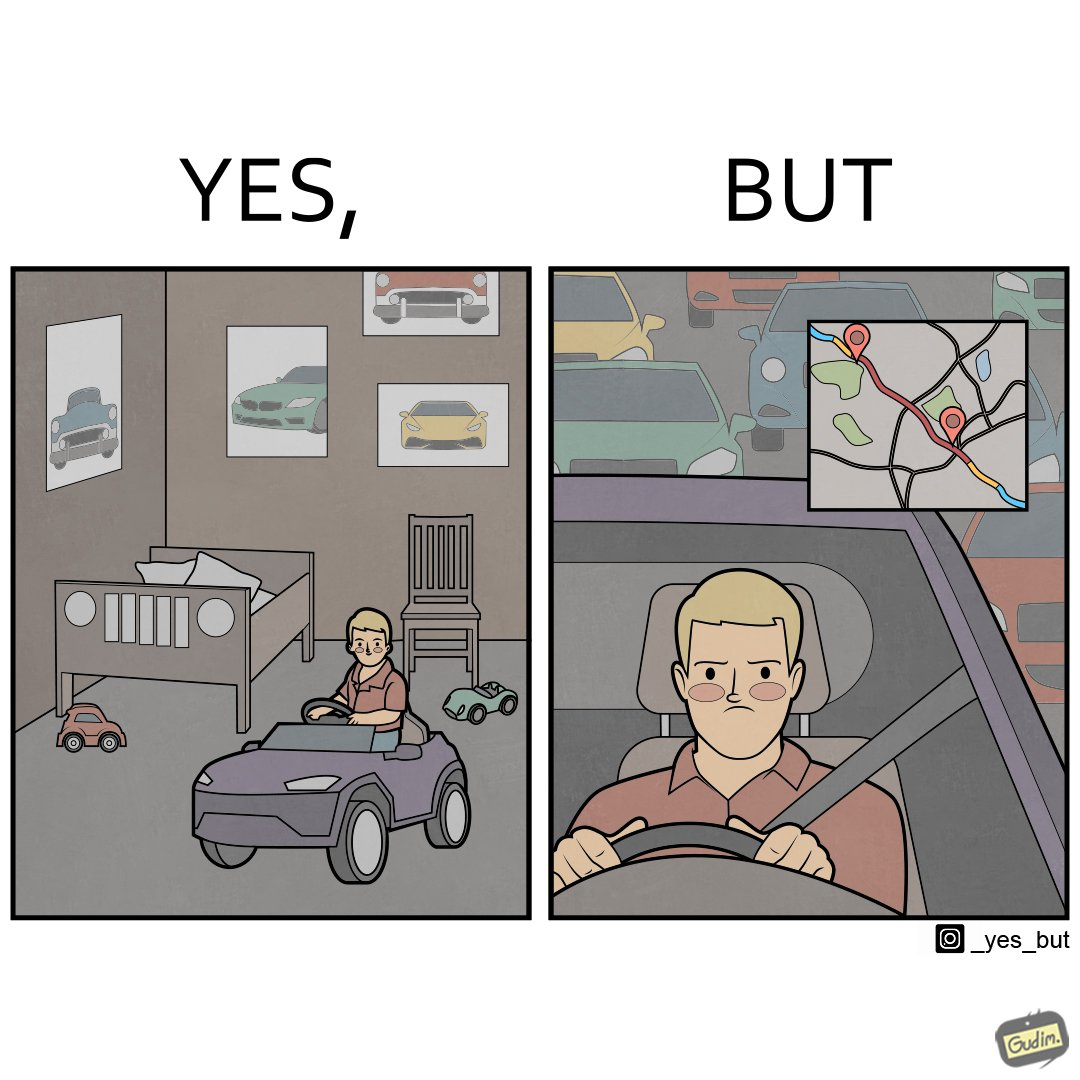Describe the contrast between the left and right parts of this image. In the left part of the image: The image shows the bedroom of a child with various small toy cars and posters of cars on the wall. The child in the picture is also riding a bigger toy car. In the right part of the image: The image shows a man annoyed by the slow traffic on his way as shown on the map while he is driving. 